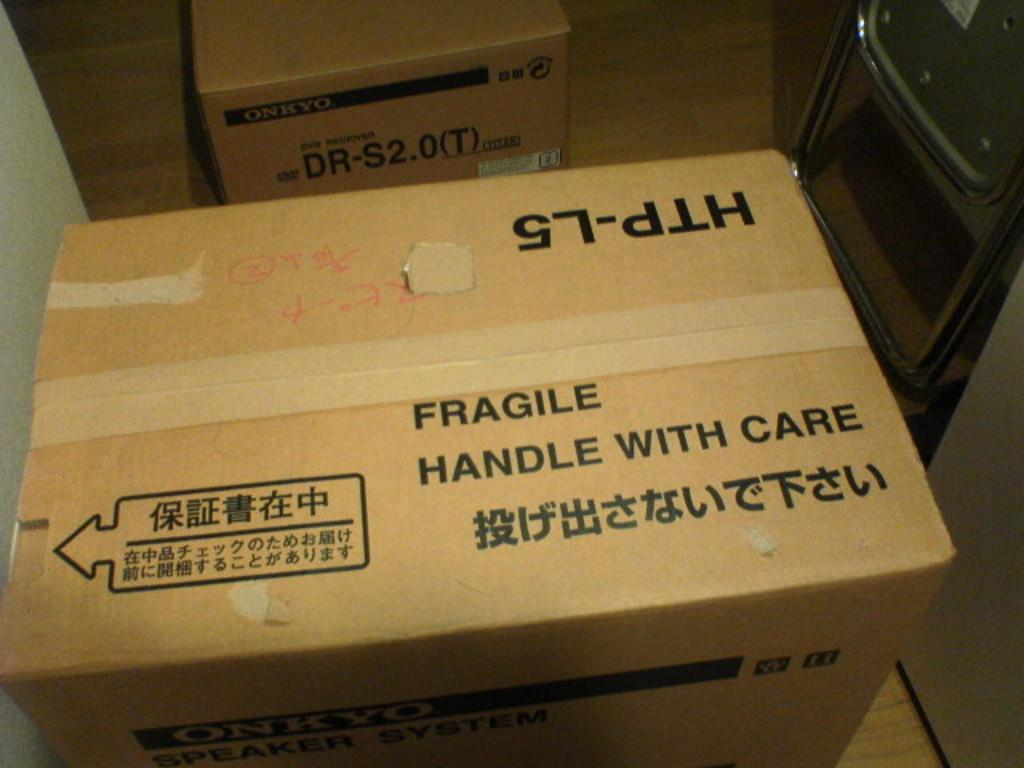<image>
Write a terse but informative summary of the picture. HTP-L5 Fragile Handle With Care Box, Onkyo Speaker System. 